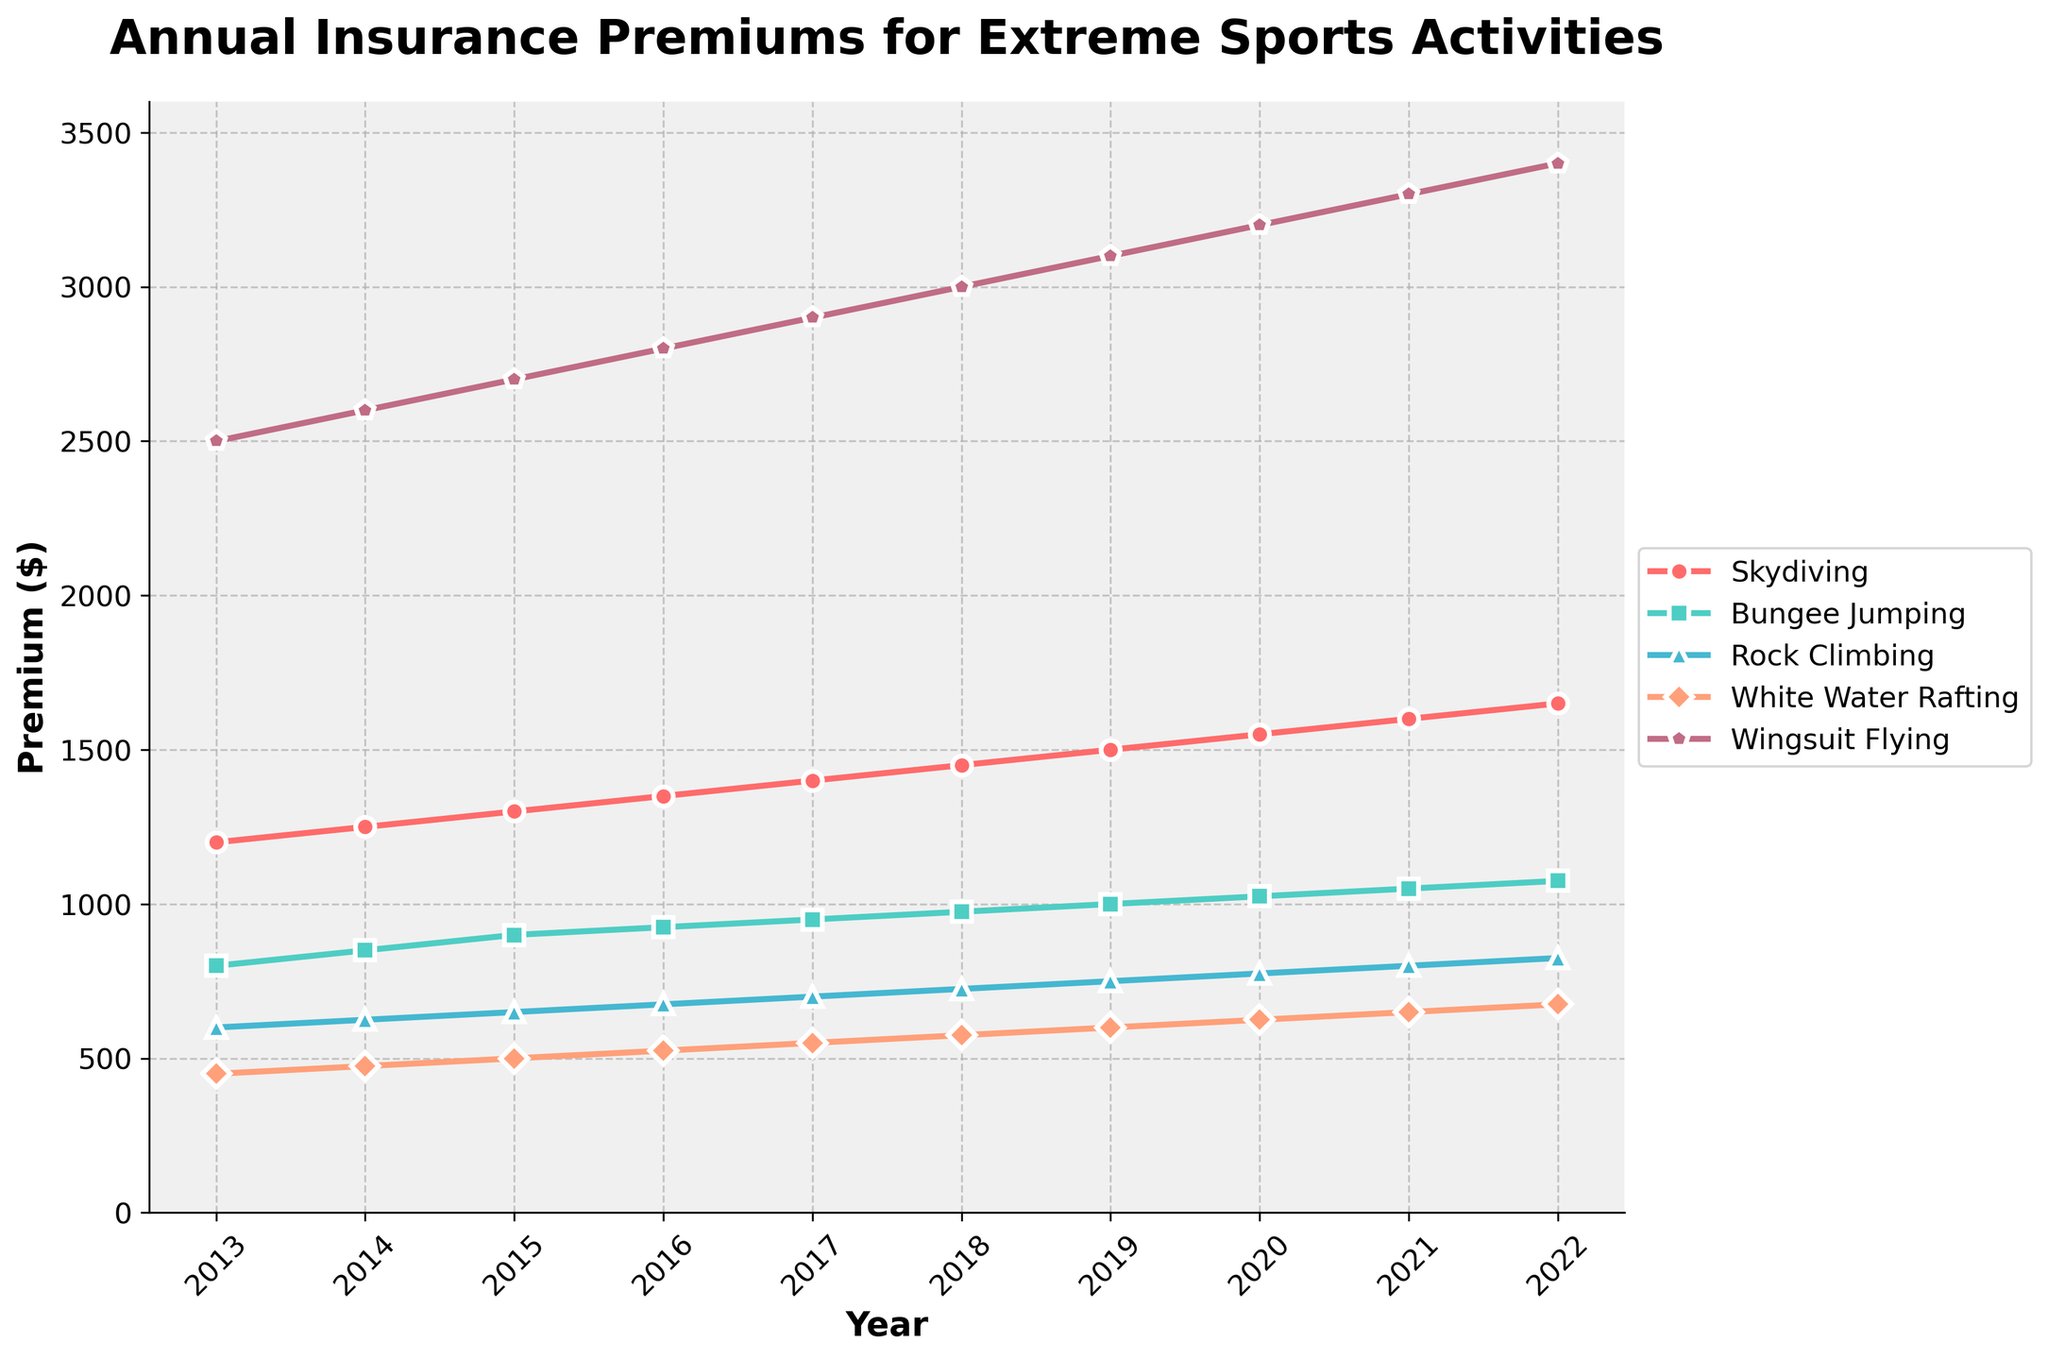What is the trend of the annual insurance premium for Skydiving over the ten years? The line for Skydiving consistently rises from 2013 to 2022, indicating a clear upward trend.
Answer: Upward trend Which extreme sport had the highest insurance premium in 2022? The line representing Wingsuit Flying is the highest in 2022.
Answer: Wingsuit Flying How much did the premium for Rock Climbing increase from 2013 to 2022? The premium for Rock Climbing in 2013 was $600, and in 2022, it was $825. The difference is $825 - $600 = $225.
Answer: $225 Compare the premiums of White Water Rafting and Bungee Jumping in 2020. Which was higher and by how much? In 2020, the premium for Bungee Jumping was $1025 and for White Water Rafting was $625. The difference is $1025 - $625 = $400.
Answer: Bungee Jumping by $400 Which year saw the highest increase in the premium for Wingsuit Flying, and how much was this increase? From 2013 to 2014, the premium for Wingsuit Flying increased the most by $2600 - $2500 = $100.
Answer: 2014, $100 What is the average insurance premium for White Water Rafting over the entire period? Sum the premiums for White Water Rafting from 2013 to 2022: 450 + 475 + 500 + 525 + 550 + 575 + 600 + 625 + 650 + 675 = 5625. The average is 5625 / 10 = 562.5.
Answer: $562.5 In which year did Skydiving and Bungee Jumping premiums have the smallest difference, and what was it? The difference between Skydiving and Bungee Jumping premiums is smallest in 2016: $1350 (Skydiving) - $925 (Bungee Jumping) = $425.
Answer: 2016, $425 Which year had the highest average premium across all the extreme sports, and what was the value? Sum the premiums for each year and then find the average. 2022 has the highest total: 1650 + 1075 + 825 + 675 + 3400 = 7625. The average for 2022 is 7625 / 5 = 1525.
Answer: 2022, $1525 Compare the growth rate of Skydiving premiums between the first half (2013-2017) and the second half (2018-2022) of the period. First half increase: $1400 - $1200 = $200. Second half increase: $1650 - $1450 = $200. Both halves have the same growth rate of $200.
Answer: Same growth rate Across the entire decade, which extreme sport showed the most consistent increase in its annual premiums? All the sports show a consistent increase, but by visually inspecting the smoothness of the increments, Skydiving seems the most consistent as it lacks sudden jumps or drops.
Answer: Skydiving 